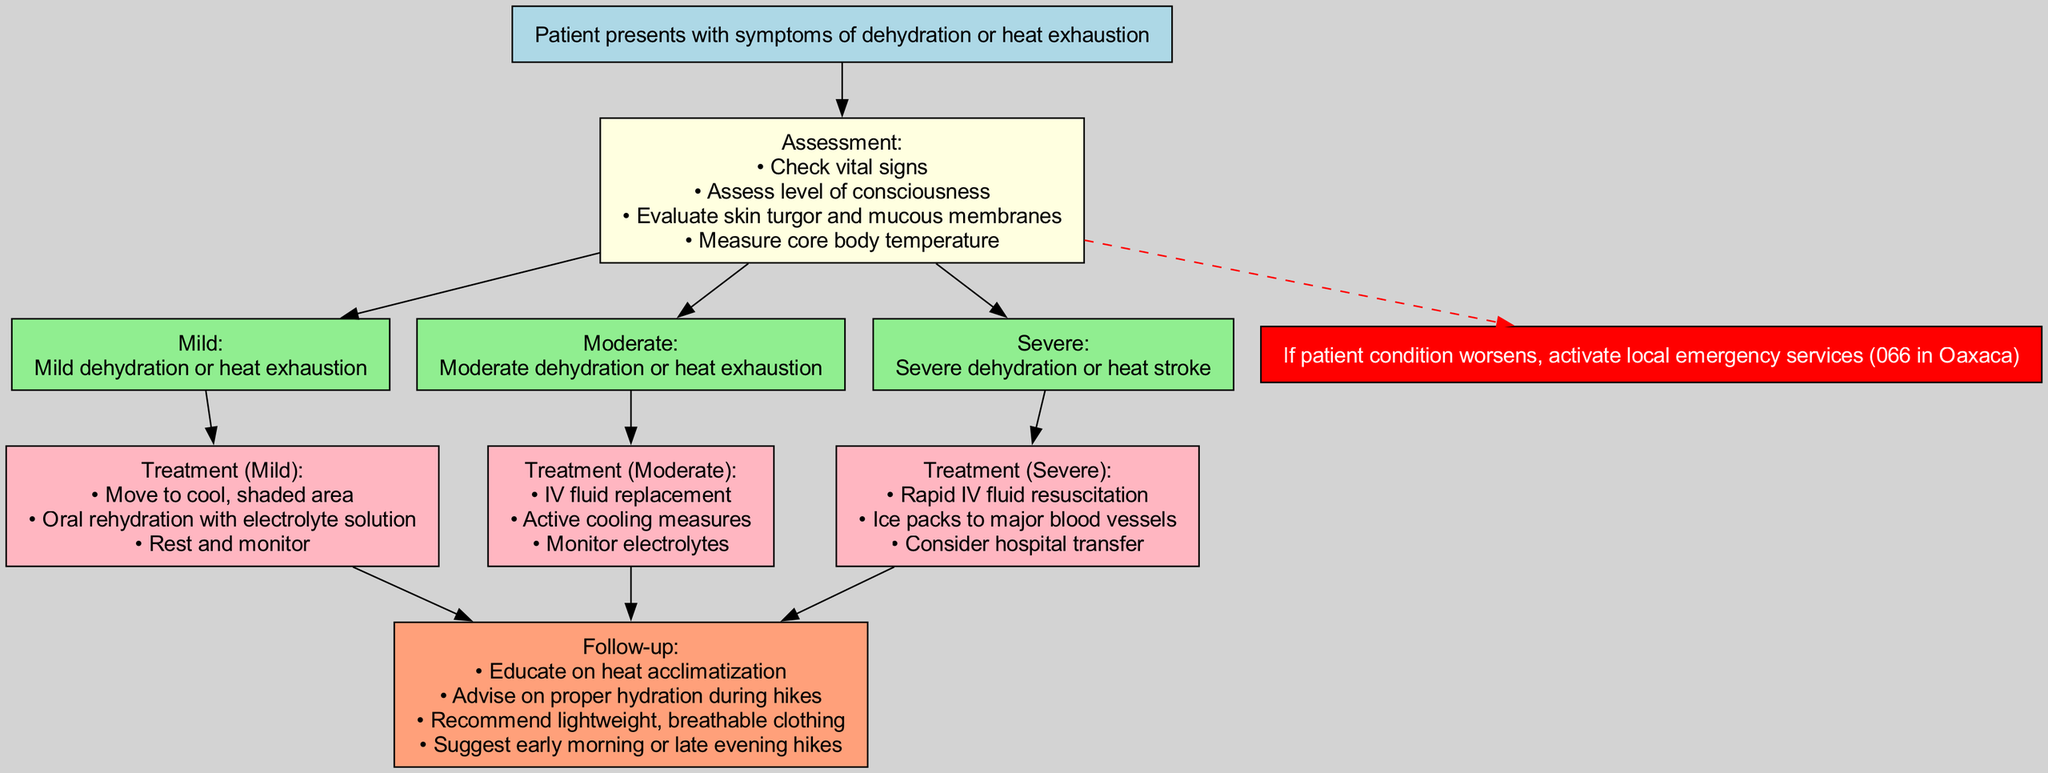What is the first step in the pathway? The first step is represented by the 'start' node, which states that the patient presents with symptoms of dehydration or heat exhaustion.
Answer: Patient presents with symptoms of dehydration or heat exhaustion How many assessments are listed in the diagram? There are four assessments listed, as indicated by the bullet points under the 'Assessment' node.
Answer: 4 What treatment is recommended for severe dehydration? The treatment for severe dehydration includes items presented below the 'Severe' diagnosis, which are rapid IV fluid resuscitation, ice packs to major blood vessels, and consideration for hospital transfer.
Answer: Rapid IV fluid resuscitation, ice packs to major blood vessels, consider hospital transfer Which node leads to emergency intervention? The emergency intervention is a dashed edge leading from the 'Assessment' node to the 'Emergency' node, indicating that if the condition worsens, emergency services should be activated.
Answer: Assessment What type of follow-up education is suggested? The follow-up node suggests educating the patient on heat acclimatization, advising proper hydration during hikes, and recommending lightweight clothing, as listed in the follow-up items.
Answer: Educate on heat acclimatization What relationship exists between diagnosis and treatment? Each diagnosis (Mild, Moderate, Severe) has a directed edge to its corresponding treatment node, showing the pathway from the diagnosis to the recommended treatments for each severity.
Answer: Diagnosis to treatment What is the purpose of the assessment checks? The purpose of the assessment checks is to evaluate the patient's condition in various ways before making a diagnosis, as shown by the listed items under the 'Assessment' node.
Answer: Evaluate patient's condition What happens if the patient's condition worsens? The diagram specifies that if the patient's condition worsens, local emergency services should be activated, which is highlighted in red in the emergency node.
Answer: Activate local emergency services (066 in Oaxaca) 